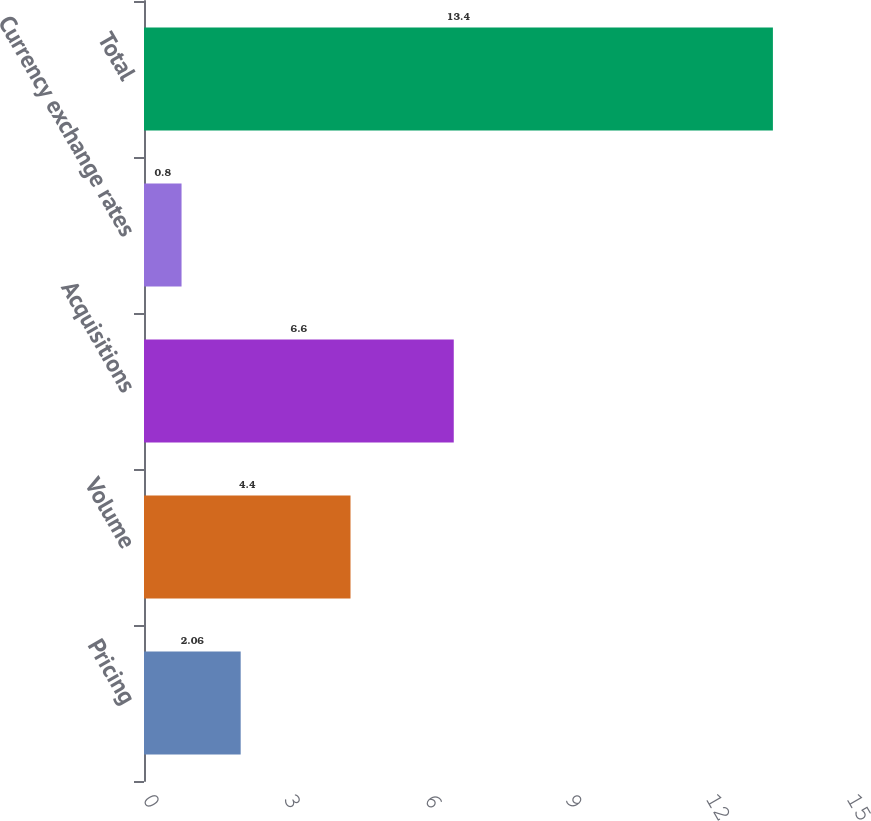<chart> <loc_0><loc_0><loc_500><loc_500><bar_chart><fcel>Pricing<fcel>Volume<fcel>Acquisitions<fcel>Currency exchange rates<fcel>Total<nl><fcel>2.06<fcel>4.4<fcel>6.6<fcel>0.8<fcel>13.4<nl></chart> 